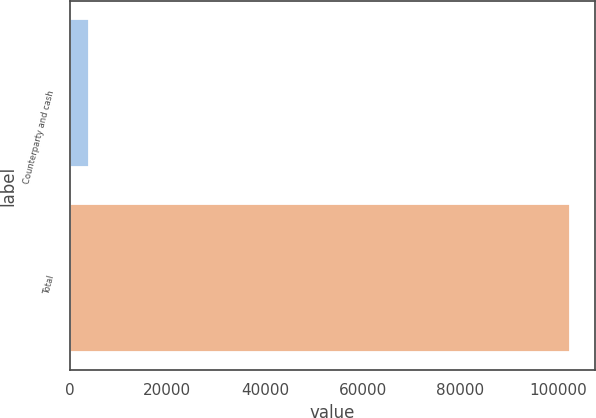<chart> <loc_0><loc_0><loc_500><loc_500><bar_chart><fcel>Counterparty and cash<fcel>Total<nl><fcel>4058<fcel>102499<nl></chart> 